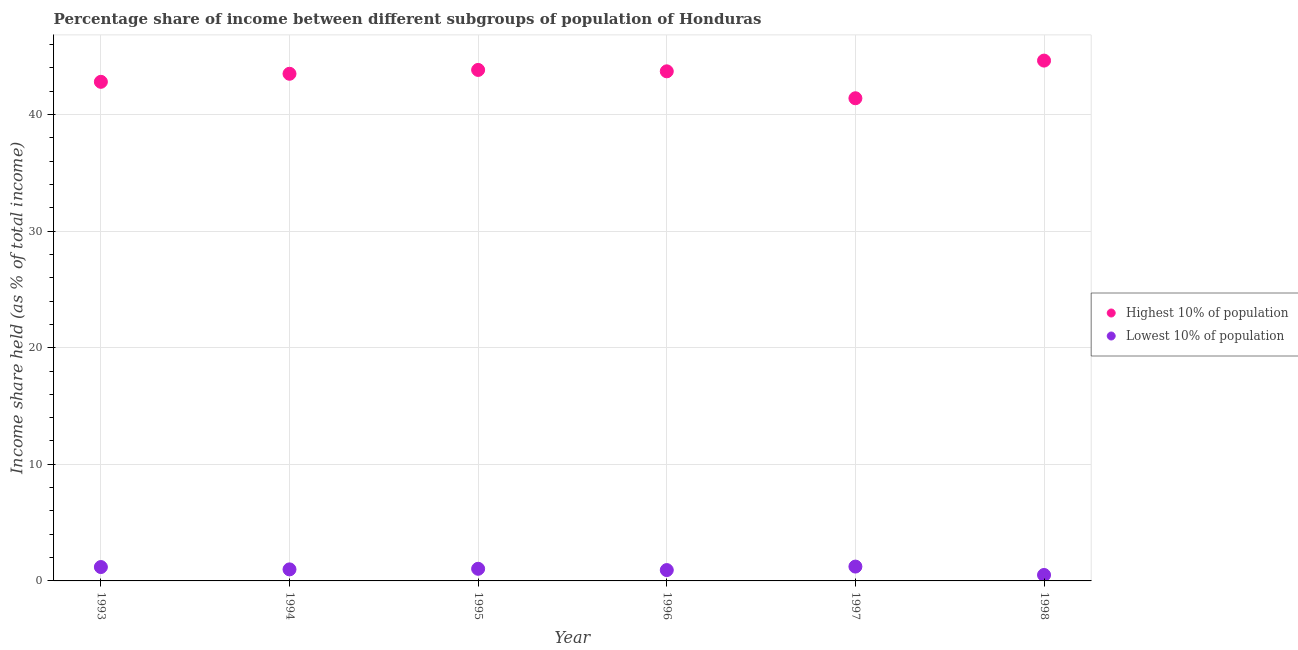How many different coloured dotlines are there?
Provide a succinct answer. 2. What is the income share held by highest 10% of the population in 1995?
Keep it short and to the point. 43.82. Across all years, what is the maximum income share held by highest 10% of the population?
Your response must be concise. 44.62. Across all years, what is the minimum income share held by lowest 10% of the population?
Offer a very short reply. 0.51. What is the total income share held by highest 10% of the population in the graph?
Give a very brief answer. 259.82. What is the difference between the income share held by highest 10% of the population in 1994 and that in 1997?
Provide a short and direct response. 2.1. What is the difference between the income share held by highest 10% of the population in 1997 and the income share held by lowest 10% of the population in 1995?
Give a very brief answer. 40.35. What is the average income share held by lowest 10% of the population per year?
Give a very brief answer. 0.98. In the year 1995, what is the difference between the income share held by lowest 10% of the population and income share held by highest 10% of the population?
Offer a terse response. -42.78. What is the ratio of the income share held by highest 10% of the population in 1994 to that in 1997?
Provide a short and direct response. 1.05. Is the income share held by lowest 10% of the population in 1995 less than that in 1998?
Your response must be concise. No. What is the difference between the highest and the second highest income share held by highest 10% of the population?
Provide a succinct answer. 0.8. What is the difference between the highest and the lowest income share held by lowest 10% of the population?
Offer a very short reply. 0.72. In how many years, is the income share held by highest 10% of the population greater than the average income share held by highest 10% of the population taken over all years?
Your answer should be compact. 4. Are the values on the major ticks of Y-axis written in scientific E-notation?
Provide a succinct answer. No. Does the graph contain grids?
Your answer should be very brief. Yes. Where does the legend appear in the graph?
Ensure brevity in your answer.  Center right. How many legend labels are there?
Ensure brevity in your answer.  2. How are the legend labels stacked?
Provide a short and direct response. Vertical. What is the title of the graph?
Your response must be concise. Percentage share of income between different subgroups of population of Honduras. What is the label or title of the Y-axis?
Keep it short and to the point. Income share held (as % of total income). What is the Income share held (as % of total income) in Highest 10% of population in 1993?
Provide a succinct answer. 42.8. What is the Income share held (as % of total income) of Lowest 10% of population in 1993?
Your response must be concise. 1.19. What is the Income share held (as % of total income) of Highest 10% of population in 1994?
Your response must be concise. 43.49. What is the Income share held (as % of total income) in Lowest 10% of population in 1994?
Provide a succinct answer. 0.99. What is the Income share held (as % of total income) of Highest 10% of population in 1995?
Your answer should be compact. 43.82. What is the Income share held (as % of total income) of Lowest 10% of population in 1995?
Ensure brevity in your answer.  1.04. What is the Income share held (as % of total income) of Highest 10% of population in 1996?
Provide a short and direct response. 43.7. What is the Income share held (as % of total income) in Lowest 10% of population in 1996?
Your answer should be compact. 0.93. What is the Income share held (as % of total income) in Highest 10% of population in 1997?
Give a very brief answer. 41.39. What is the Income share held (as % of total income) of Lowest 10% of population in 1997?
Give a very brief answer. 1.23. What is the Income share held (as % of total income) of Highest 10% of population in 1998?
Provide a succinct answer. 44.62. What is the Income share held (as % of total income) of Lowest 10% of population in 1998?
Offer a very short reply. 0.51. Across all years, what is the maximum Income share held (as % of total income) in Highest 10% of population?
Make the answer very short. 44.62. Across all years, what is the maximum Income share held (as % of total income) of Lowest 10% of population?
Make the answer very short. 1.23. Across all years, what is the minimum Income share held (as % of total income) of Highest 10% of population?
Offer a very short reply. 41.39. Across all years, what is the minimum Income share held (as % of total income) in Lowest 10% of population?
Provide a short and direct response. 0.51. What is the total Income share held (as % of total income) in Highest 10% of population in the graph?
Your response must be concise. 259.82. What is the total Income share held (as % of total income) in Lowest 10% of population in the graph?
Offer a terse response. 5.89. What is the difference between the Income share held (as % of total income) in Highest 10% of population in 1993 and that in 1994?
Provide a short and direct response. -0.69. What is the difference between the Income share held (as % of total income) of Lowest 10% of population in 1993 and that in 1994?
Your response must be concise. 0.2. What is the difference between the Income share held (as % of total income) in Highest 10% of population in 1993 and that in 1995?
Your answer should be compact. -1.02. What is the difference between the Income share held (as % of total income) in Lowest 10% of population in 1993 and that in 1996?
Provide a short and direct response. 0.26. What is the difference between the Income share held (as % of total income) of Highest 10% of population in 1993 and that in 1997?
Your answer should be compact. 1.41. What is the difference between the Income share held (as % of total income) of Lowest 10% of population in 1993 and that in 1997?
Provide a short and direct response. -0.04. What is the difference between the Income share held (as % of total income) of Highest 10% of population in 1993 and that in 1998?
Keep it short and to the point. -1.82. What is the difference between the Income share held (as % of total income) in Lowest 10% of population in 1993 and that in 1998?
Your answer should be compact. 0.68. What is the difference between the Income share held (as % of total income) of Highest 10% of population in 1994 and that in 1995?
Offer a terse response. -0.33. What is the difference between the Income share held (as % of total income) in Lowest 10% of population in 1994 and that in 1995?
Provide a short and direct response. -0.05. What is the difference between the Income share held (as % of total income) of Highest 10% of population in 1994 and that in 1996?
Offer a terse response. -0.21. What is the difference between the Income share held (as % of total income) of Lowest 10% of population in 1994 and that in 1997?
Provide a short and direct response. -0.24. What is the difference between the Income share held (as % of total income) of Highest 10% of population in 1994 and that in 1998?
Offer a terse response. -1.13. What is the difference between the Income share held (as % of total income) of Lowest 10% of population in 1994 and that in 1998?
Your answer should be very brief. 0.48. What is the difference between the Income share held (as % of total income) in Highest 10% of population in 1995 and that in 1996?
Keep it short and to the point. 0.12. What is the difference between the Income share held (as % of total income) of Lowest 10% of population in 1995 and that in 1996?
Give a very brief answer. 0.11. What is the difference between the Income share held (as % of total income) in Highest 10% of population in 1995 and that in 1997?
Your answer should be very brief. 2.43. What is the difference between the Income share held (as % of total income) in Lowest 10% of population in 1995 and that in 1997?
Your response must be concise. -0.19. What is the difference between the Income share held (as % of total income) of Highest 10% of population in 1995 and that in 1998?
Give a very brief answer. -0.8. What is the difference between the Income share held (as % of total income) in Lowest 10% of population in 1995 and that in 1998?
Your answer should be compact. 0.53. What is the difference between the Income share held (as % of total income) of Highest 10% of population in 1996 and that in 1997?
Keep it short and to the point. 2.31. What is the difference between the Income share held (as % of total income) in Lowest 10% of population in 1996 and that in 1997?
Ensure brevity in your answer.  -0.3. What is the difference between the Income share held (as % of total income) of Highest 10% of population in 1996 and that in 1998?
Ensure brevity in your answer.  -0.92. What is the difference between the Income share held (as % of total income) of Lowest 10% of population in 1996 and that in 1998?
Provide a succinct answer. 0.42. What is the difference between the Income share held (as % of total income) of Highest 10% of population in 1997 and that in 1998?
Offer a very short reply. -3.23. What is the difference between the Income share held (as % of total income) in Lowest 10% of population in 1997 and that in 1998?
Make the answer very short. 0.72. What is the difference between the Income share held (as % of total income) of Highest 10% of population in 1993 and the Income share held (as % of total income) of Lowest 10% of population in 1994?
Provide a short and direct response. 41.81. What is the difference between the Income share held (as % of total income) in Highest 10% of population in 1993 and the Income share held (as % of total income) in Lowest 10% of population in 1995?
Offer a terse response. 41.76. What is the difference between the Income share held (as % of total income) of Highest 10% of population in 1993 and the Income share held (as % of total income) of Lowest 10% of population in 1996?
Your answer should be compact. 41.87. What is the difference between the Income share held (as % of total income) in Highest 10% of population in 1993 and the Income share held (as % of total income) in Lowest 10% of population in 1997?
Your response must be concise. 41.57. What is the difference between the Income share held (as % of total income) in Highest 10% of population in 1993 and the Income share held (as % of total income) in Lowest 10% of population in 1998?
Your answer should be very brief. 42.29. What is the difference between the Income share held (as % of total income) in Highest 10% of population in 1994 and the Income share held (as % of total income) in Lowest 10% of population in 1995?
Give a very brief answer. 42.45. What is the difference between the Income share held (as % of total income) of Highest 10% of population in 1994 and the Income share held (as % of total income) of Lowest 10% of population in 1996?
Provide a short and direct response. 42.56. What is the difference between the Income share held (as % of total income) of Highest 10% of population in 1994 and the Income share held (as % of total income) of Lowest 10% of population in 1997?
Ensure brevity in your answer.  42.26. What is the difference between the Income share held (as % of total income) of Highest 10% of population in 1994 and the Income share held (as % of total income) of Lowest 10% of population in 1998?
Provide a succinct answer. 42.98. What is the difference between the Income share held (as % of total income) of Highest 10% of population in 1995 and the Income share held (as % of total income) of Lowest 10% of population in 1996?
Ensure brevity in your answer.  42.89. What is the difference between the Income share held (as % of total income) of Highest 10% of population in 1995 and the Income share held (as % of total income) of Lowest 10% of population in 1997?
Make the answer very short. 42.59. What is the difference between the Income share held (as % of total income) in Highest 10% of population in 1995 and the Income share held (as % of total income) in Lowest 10% of population in 1998?
Give a very brief answer. 43.31. What is the difference between the Income share held (as % of total income) in Highest 10% of population in 1996 and the Income share held (as % of total income) in Lowest 10% of population in 1997?
Your answer should be compact. 42.47. What is the difference between the Income share held (as % of total income) in Highest 10% of population in 1996 and the Income share held (as % of total income) in Lowest 10% of population in 1998?
Provide a succinct answer. 43.19. What is the difference between the Income share held (as % of total income) in Highest 10% of population in 1997 and the Income share held (as % of total income) in Lowest 10% of population in 1998?
Give a very brief answer. 40.88. What is the average Income share held (as % of total income) of Highest 10% of population per year?
Offer a terse response. 43.3. What is the average Income share held (as % of total income) in Lowest 10% of population per year?
Provide a short and direct response. 0.98. In the year 1993, what is the difference between the Income share held (as % of total income) in Highest 10% of population and Income share held (as % of total income) in Lowest 10% of population?
Your answer should be very brief. 41.61. In the year 1994, what is the difference between the Income share held (as % of total income) in Highest 10% of population and Income share held (as % of total income) in Lowest 10% of population?
Give a very brief answer. 42.5. In the year 1995, what is the difference between the Income share held (as % of total income) in Highest 10% of population and Income share held (as % of total income) in Lowest 10% of population?
Give a very brief answer. 42.78. In the year 1996, what is the difference between the Income share held (as % of total income) of Highest 10% of population and Income share held (as % of total income) of Lowest 10% of population?
Offer a terse response. 42.77. In the year 1997, what is the difference between the Income share held (as % of total income) in Highest 10% of population and Income share held (as % of total income) in Lowest 10% of population?
Provide a succinct answer. 40.16. In the year 1998, what is the difference between the Income share held (as % of total income) of Highest 10% of population and Income share held (as % of total income) of Lowest 10% of population?
Provide a short and direct response. 44.11. What is the ratio of the Income share held (as % of total income) of Highest 10% of population in 1993 to that in 1994?
Make the answer very short. 0.98. What is the ratio of the Income share held (as % of total income) in Lowest 10% of population in 1993 to that in 1994?
Provide a succinct answer. 1.2. What is the ratio of the Income share held (as % of total income) of Highest 10% of population in 1993 to that in 1995?
Ensure brevity in your answer.  0.98. What is the ratio of the Income share held (as % of total income) in Lowest 10% of population in 1993 to that in 1995?
Provide a succinct answer. 1.14. What is the ratio of the Income share held (as % of total income) in Highest 10% of population in 1993 to that in 1996?
Your answer should be very brief. 0.98. What is the ratio of the Income share held (as % of total income) of Lowest 10% of population in 1993 to that in 1996?
Ensure brevity in your answer.  1.28. What is the ratio of the Income share held (as % of total income) in Highest 10% of population in 1993 to that in 1997?
Offer a very short reply. 1.03. What is the ratio of the Income share held (as % of total income) of Lowest 10% of population in 1993 to that in 1997?
Make the answer very short. 0.97. What is the ratio of the Income share held (as % of total income) of Highest 10% of population in 1993 to that in 1998?
Offer a very short reply. 0.96. What is the ratio of the Income share held (as % of total income) of Lowest 10% of population in 1993 to that in 1998?
Your answer should be very brief. 2.33. What is the ratio of the Income share held (as % of total income) of Lowest 10% of population in 1994 to that in 1995?
Make the answer very short. 0.95. What is the ratio of the Income share held (as % of total income) of Lowest 10% of population in 1994 to that in 1996?
Provide a succinct answer. 1.06. What is the ratio of the Income share held (as % of total income) in Highest 10% of population in 1994 to that in 1997?
Offer a very short reply. 1.05. What is the ratio of the Income share held (as % of total income) in Lowest 10% of population in 1994 to that in 1997?
Your response must be concise. 0.8. What is the ratio of the Income share held (as % of total income) in Highest 10% of population in 1994 to that in 1998?
Ensure brevity in your answer.  0.97. What is the ratio of the Income share held (as % of total income) of Lowest 10% of population in 1994 to that in 1998?
Your response must be concise. 1.94. What is the ratio of the Income share held (as % of total income) in Lowest 10% of population in 1995 to that in 1996?
Provide a short and direct response. 1.12. What is the ratio of the Income share held (as % of total income) in Highest 10% of population in 1995 to that in 1997?
Ensure brevity in your answer.  1.06. What is the ratio of the Income share held (as % of total income) of Lowest 10% of population in 1995 to that in 1997?
Your response must be concise. 0.85. What is the ratio of the Income share held (as % of total income) in Highest 10% of population in 1995 to that in 1998?
Offer a terse response. 0.98. What is the ratio of the Income share held (as % of total income) in Lowest 10% of population in 1995 to that in 1998?
Your answer should be very brief. 2.04. What is the ratio of the Income share held (as % of total income) of Highest 10% of population in 1996 to that in 1997?
Your response must be concise. 1.06. What is the ratio of the Income share held (as % of total income) in Lowest 10% of population in 1996 to that in 1997?
Offer a terse response. 0.76. What is the ratio of the Income share held (as % of total income) of Highest 10% of population in 1996 to that in 1998?
Your response must be concise. 0.98. What is the ratio of the Income share held (as % of total income) in Lowest 10% of population in 1996 to that in 1998?
Your answer should be compact. 1.82. What is the ratio of the Income share held (as % of total income) in Highest 10% of population in 1997 to that in 1998?
Give a very brief answer. 0.93. What is the ratio of the Income share held (as % of total income) in Lowest 10% of population in 1997 to that in 1998?
Your answer should be compact. 2.41. What is the difference between the highest and the lowest Income share held (as % of total income) of Highest 10% of population?
Give a very brief answer. 3.23. What is the difference between the highest and the lowest Income share held (as % of total income) of Lowest 10% of population?
Provide a succinct answer. 0.72. 